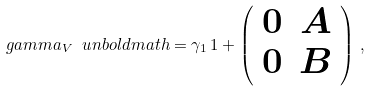<formula> <loc_0><loc_0><loc_500><loc_500>\boldmath { \ g a m m a _ { V } } \ u n b o l d m a t h = \gamma _ { 1 } \, { 1 } + \left ( \begin{array} { c c } { 0 } & { { { A } } } \\ { 0 } & { { { B } } } \end{array} \right ) \, ,</formula> 